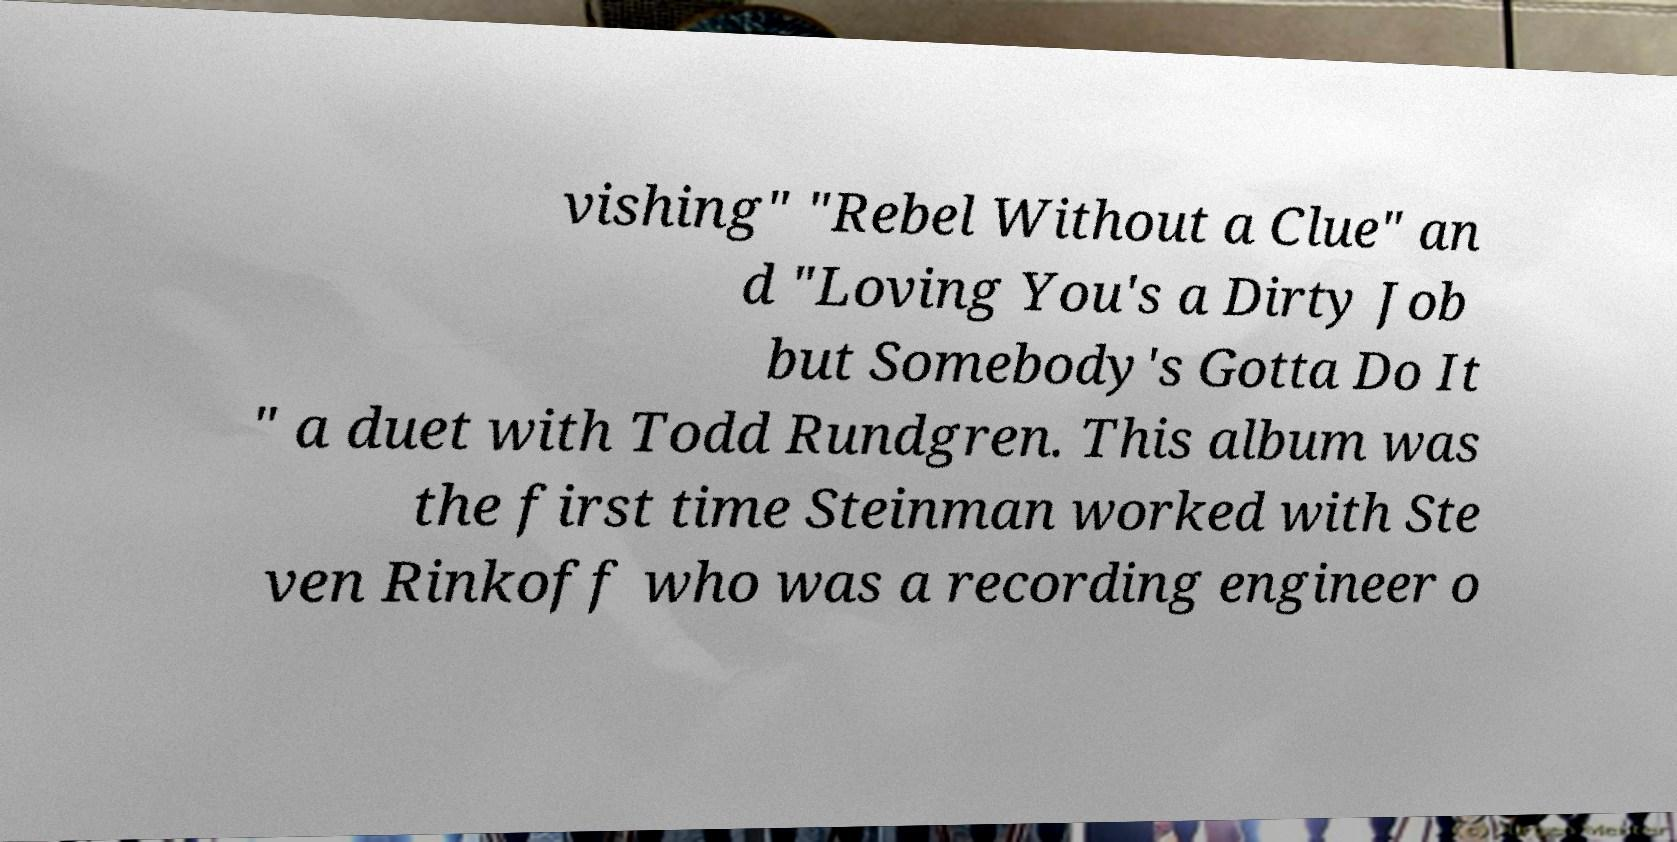Please identify and transcribe the text found in this image. vishing" "Rebel Without a Clue" an d "Loving You's a Dirty Job but Somebody's Gotta Do It " a duet with Todd Rundgren. This album was the first time Steinman worked with Ste ven Rinkoff who was a recording engineer o 